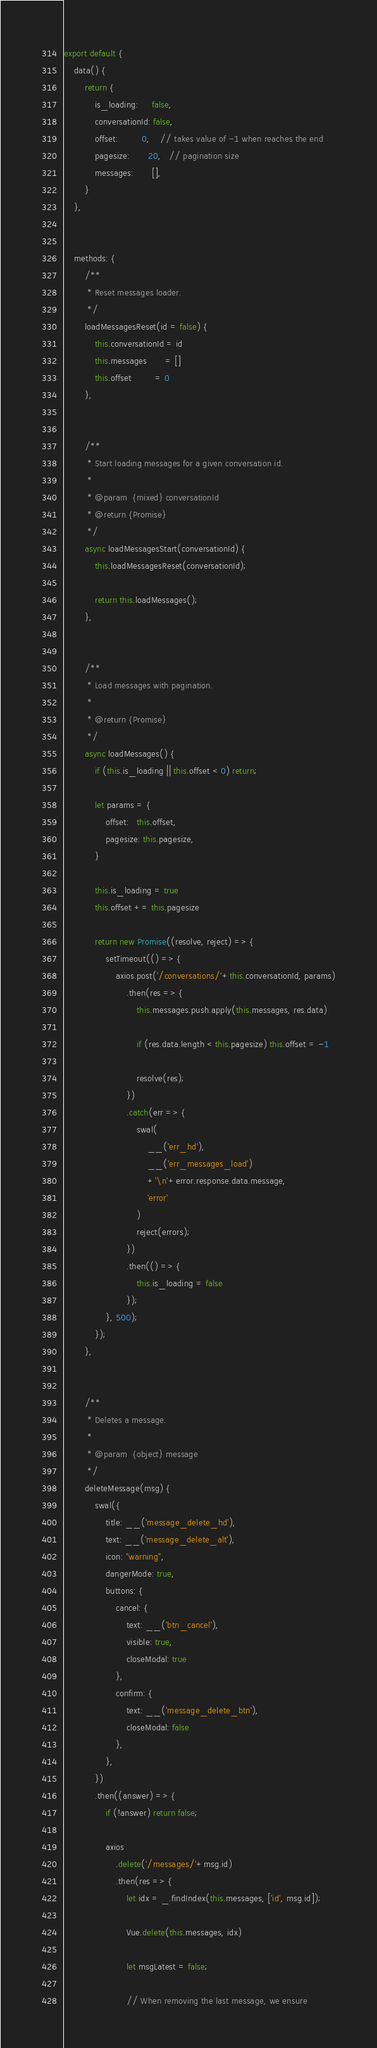Convert code to text. <code><loc_0><loc_0><loc_500><loc_500><_JavaScript_>export default {
    data() {
        return {
            is_loading:     false,
            conversationId: false,
            offset:         0,    // takes value of -1 when reaches the end
            pagesize:       20,   // pagination size
            messages:       [],
        }
    },


    methods: {
        /**
         * Reset messages loader.
         */
        loadMessagesReset(id = false) {
            this.conversationId = id
            this.messages       = []
            this.offset         = 0
        },


        /**
         * Start loading messages for a given conversation id.
         *
         * @param  {mixed} conversationId
         * @return {Promise}
         */
        async loadMessagesStart(conversationId) {
            this.loadMessagesReset(conversationId);

            return this.loadMessages();
        },


        /**
         * Load messages with pagination.
         *
         * @return {Promise}
         */
        async loadMessages() {
            if (this.is_loading || this.offset < 0) return;

            let params = {
                offset:   this.offset,
                pagesize: this.pagesize,
            }

            this.is_loading = true
            this.offset += this.pagesize

            return new Promise((resolve, reject) => {
                setTimeout(() => {
                    axios.post('/conversations/'+this.conversationId, params)
                        .then(res => {
                            this.messages.push.apply(this.messages, res.data)

                            if (res.data.length < this.pagesize) this.offset = -1

                            resolve(res);
                        })
                        .catch(err => {
                            swal(
                                __('err_hd'),
                                __('err_messages_load')
                                +'\n'+error.response.data.message,
                                'error'
                            )
                            reject(errors);
                        })
                        .then(() => {
                            this.is_loading = false
                        });
                }, 500);
            });
        },


        /**
         * Deletes a message.
         *
         * @param  {object} message
         */
        deleteMessage(msg) {
            swal({
                title: __('message_delete_hd'),
                text: __('message_delete_alt'),
                icon: "warning",
                dangerMode: true,
                buttons: {
                    cancel: {
                        text: __('btn_cancel'),
                        visible: true,
                        closeModal: true
                    },
                    confirm: {
                        text: __('message_delete_btn'),
                        closeModal: false
                    },
                },
            })
            .then((answer) => {
                if (!answer) return false;

                axios
                    .delete('/messages/'+msg.id)
                    .then(res => {
                        let idx = _.findIndex(this.messages, ['id', msg.id]);

                        Vue.delete(this.messages, idx)

                        let msgLatest = false;

                        // When removing the last message, we ensure</code> 